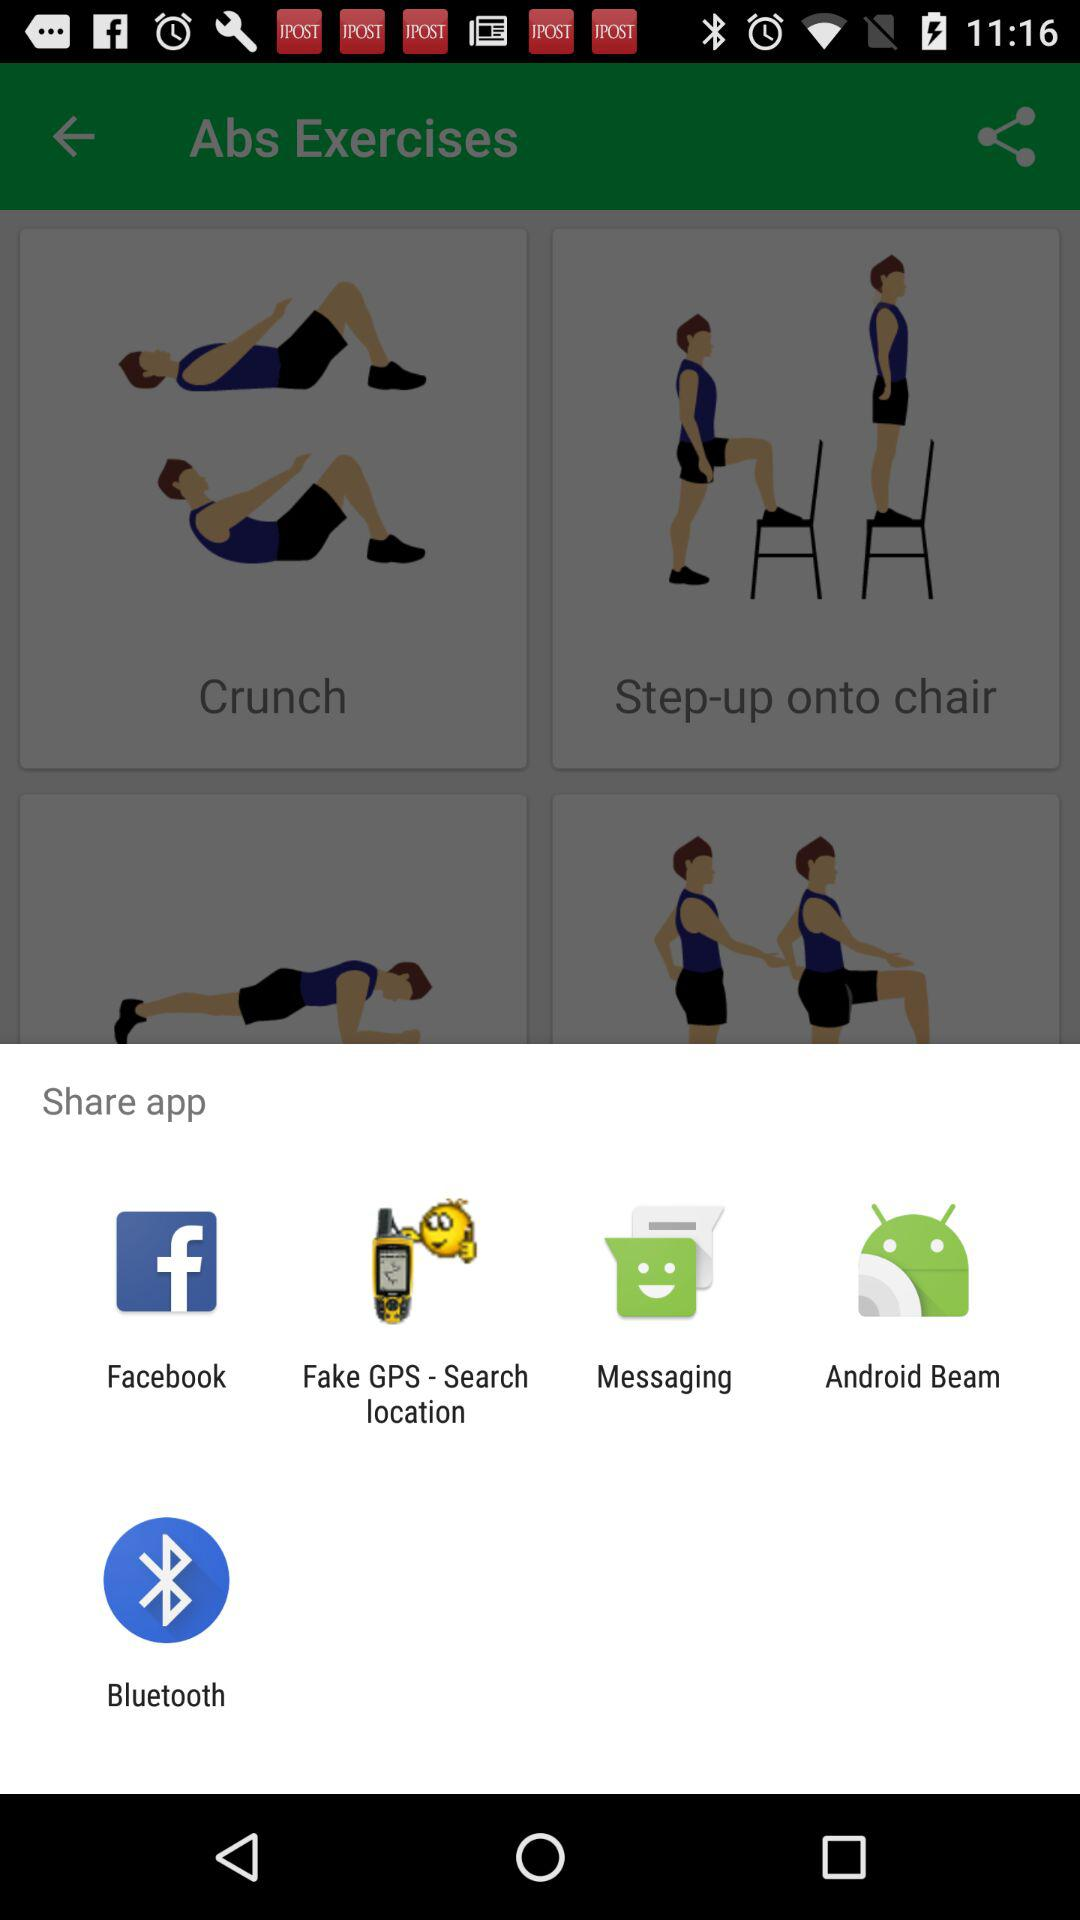How many calories do crunches burn?
When the provided information is insufficient, respond with <no answer>. <no answer> 